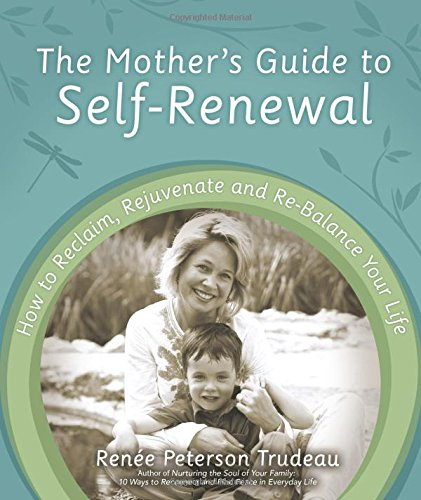How can this book be beneficial to a new mother? This book can be incredibly beneficial to new mothers as it provides strategies and tips on how to manage the unique challenges of motherhood. Emphasis is placed on self-care and developing a support network, all of which are crucial for adapting to this new life phase. 